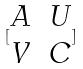Convert formula to latex. <formula><loc_0><loc_0><loc_500><loc_500>[ \begin{matrix} A & U \\ V & C \end{matrix} ]</formula> 